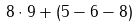Convert formula to latex. <formula><loc_0><loc_0><loc_500><loc_500>8 \cdot 9 + ( 5 - 6 - 8 )</formula> 